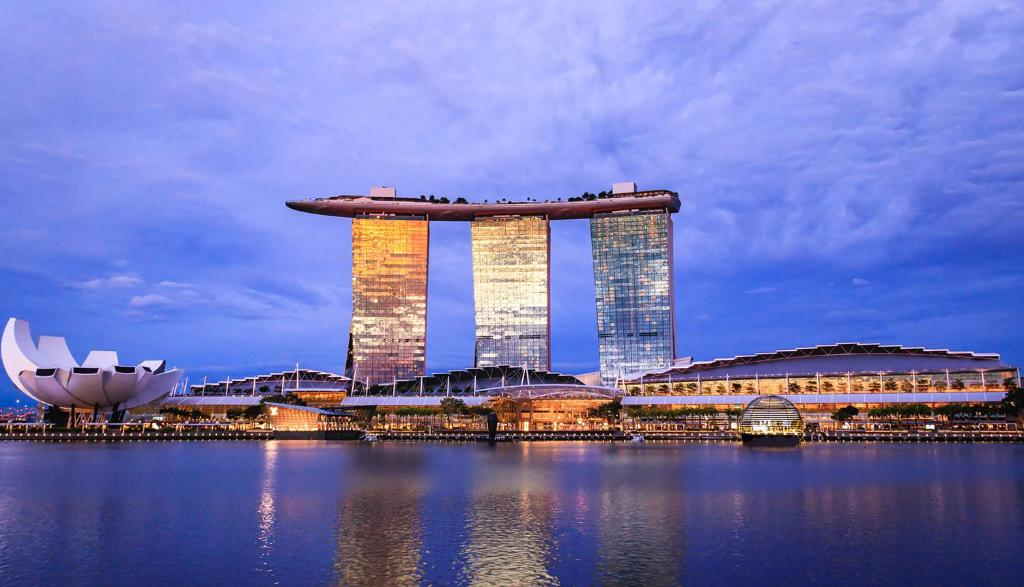What activities can visitors enjoy at Marina Bay Sands? Visitors at Marina Bay Sands can indulge in a myriad of activities. They can swim in the iconic infinity pool on the SkyPark, offering a breathtaking view of the city. There's amplified entertainment at the casino, theaters, and ArtScience Museum. Shopping enthusiasts can visit The Shoppes, with a variety of luxury brands. Dining options range from high-end restaurants helmed by celebrity chefs to casual eateries. The SkyPark also features a lush garden and observation deck for a serene escape. What kind of view can a visitor expect from the SkyPark's infinity pool? From the infinity pool in the SkyPark, visitors can experience an unparalleled panoramic view of Singapore's skyline. The pool seemingly merges with the horizon, creating an illusion of endless water against the backdrop of the bustling city. Landmarks such as the Singapore Flyer, Gardens by the Bay, and the bustling Marina Bay area are clearly visible. As night falls, the city lights up, offering a dazzling spectacle from this elevated vantage point. 